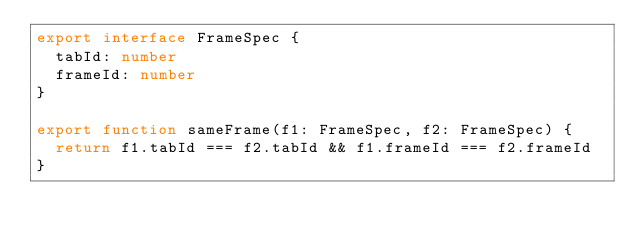<code> <loc_0><loc_0><loc_500><loc_500><_TypeScript_>export interface FrameSpec {
  tabId: number
  frameId: number
}

export function sameFrame(f1: FrameSpec, f2: FrameSpec) {
  return f1.tabId === f2.tabId && f1.frameId === f2.frameId
}
</code> 